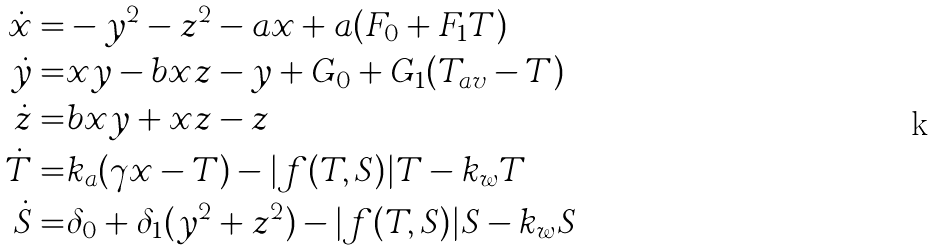<formula> <loc_0><loc_0><loc_500><loc_500>\dot { x } = & - y ^ { 2 } - z ^ { 2 } - a x + a ( F _ { 0 } + F _ { 1 } T ) \\ \dot { y } = & x y - b x z - y + G _ { 0 } + G _ { 1 } ( T _ { a v } - T ) \\ \dot { z } = & b x y + x z - z \\ \dot { T } = & k _ { a } ( \gamma x - T ) - | f ( T , S ) | T - k _ { w } T \\ \dot { S } = & \delta _ { 0 } + \delta _ { 1 } ( y ^ { 2 } + z ^ { 2 } ) - | f ( T , S ) | S - k _ { w } S</formula> 